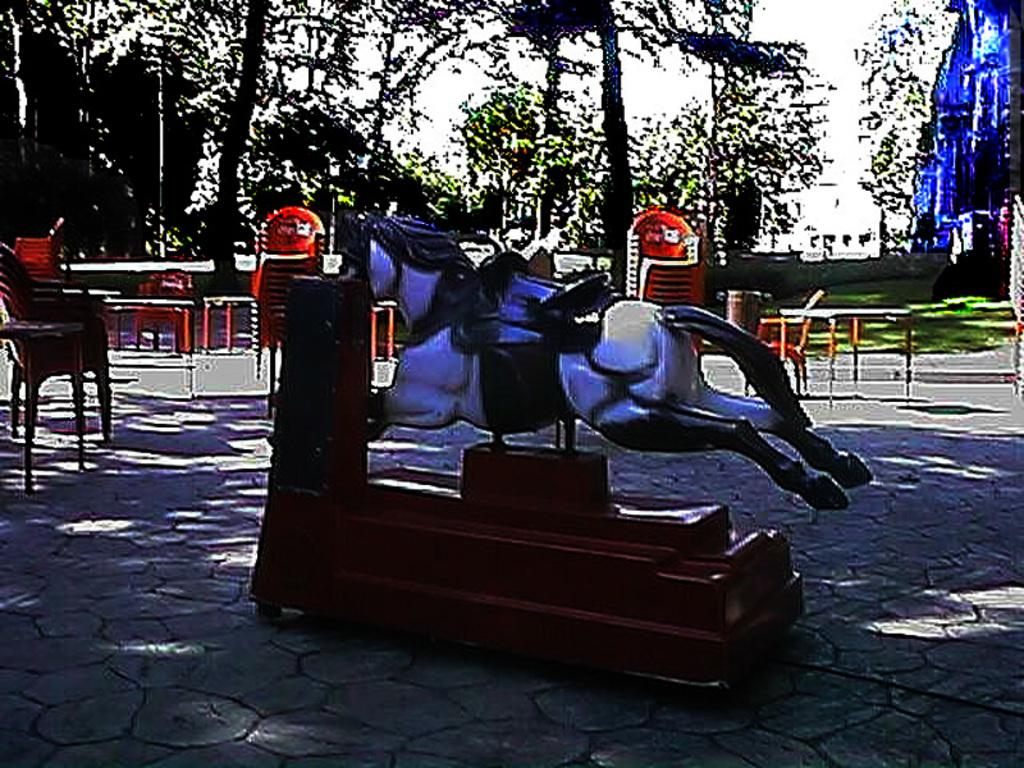What object is the main subject of the image? There is a wooden horse in the image. Where is the wooden horse located? The wooden horse is on a wooden bench. What can be seen in the background of the image? There are trees, chairs, and a table visible in the background of the image. What type of needle is being used for learning in the image? There is no needle or learning activity present in the image. How many cards are visible on the table in the image? There are no cards visible on the table in the image. 